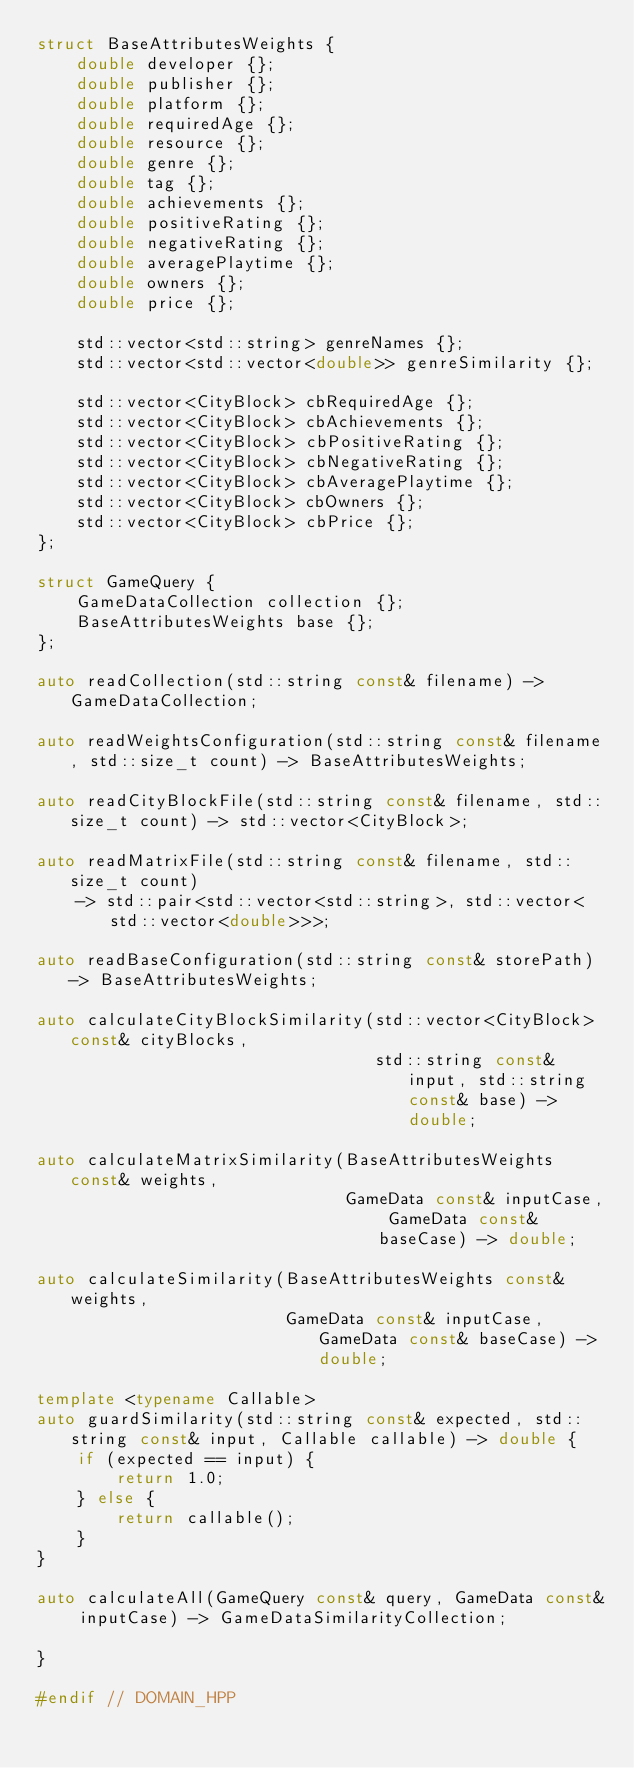Convert code to text. <code><loc_0><loc_0><loc_500><loc_500><_C++_>struct BaseAttributesWeights {
    double developer {};
    double publisher {};
    double platform {};
    double requiredAge {};
    double resource {};
    double genre {};
    double tag {};
    double achievements {};
    double positiveRating {};
    double negativeRating {};
    double averagePlaytime {};
    double owners {};
    double price {};

    std::vector<std::string> genreNames {};
    std::vector<std::vector<double>> genreSimilarity {};

    std::vector<CityBlock> cbRequiredAge {};
    std::vector<CityBlock> cbAchievements {};
    std::vector<CityBlock> cbPositiveRating {};
    std::vector<CityBlock> cbNegativeRating {};
    std::vector<CityBlock> cbAveragePlaytime {};
    std::vector<CityBlock> cbOwners {};
    std::vector<CityBlock> cbPrice {};
};

struct GameQuery {
    GameDataCollection collection {};
    BaseAttributesWeights base {};
};

auto readCollection(std::string const& filename) -> GameDataCollection;

auto readWeightsConfiguration(std::string const& filename, std::size_t count) -> BaseAttributesWeights;

auto readCityBlockFile(std::string const& filename, std::size_t count) -> std::vector<CityBlock>;

auto readMatrixFile(std::string const& filename, std::size_t count)
    -> std::pair<std::vector<std::string>, std::vector<std::vector<double>>>;

auto readBaseConfiguration(std::string const& storePath) -> BaseAttributesWeights;

auto calculateCityBlockSimilarity(std::vector<CityBlock> const& cityBlocks,
                                  std::string const& input, std::string const& base) -> double;

auto calculateMatrixSimilarity(BaseAttributesWeights const& weights,
                               GameData const& inputCase, GameData const& baseCase) -> double;

auto calculateSimilarity(BaseAttributesWeights const& weights,
                         GameData const& inputCase, GameData const& baseCase) -> double;

template <typename Callable>
auto guardSimilarity(std::string const& expected, std::string const& input, Callable callable) -> double {
    if (expected == input) {
        return 1.0;
    } else {
        return callable();
    }
}

auto calculateAll(GameQuery const& query, GameData const& inputCase) -> GameDataSimilarityCollection;

}

#endif // DOMAIN_HPP
</code> 